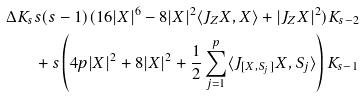<formula> <loc_0><loc_0><loc_500><loc_500>\Delta K _ { s } & s ( s - 1 ) ( 1 6 | X | ^ { 6 } - 8 | X | ^ { 2 } \langle J _ { Z } X , X \rangle + | J _ { Z } X | ^ { 2 } ) K _ { s - 2 } \\ & + s \left ( 4 p | X | ^ { 2 } + 8 | X | ^ { 2 } + \frac { 1 } { 2 } \sum _ { j = 1 } ^ { p } \langle J _ { [ X , S _ { j } ] } X , S _ { j } \rangle \right ) K _ { s - 1 }</formula> 